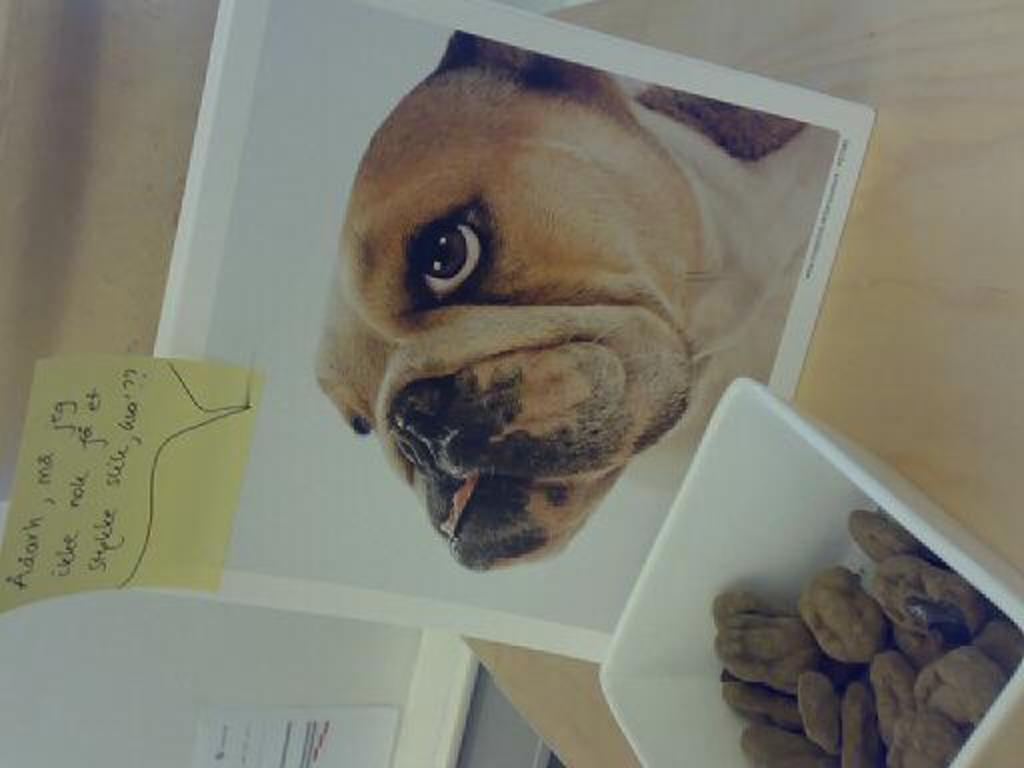Describe this image in one or two sentences. In this picture we can see a bowl with food items in it, photo of a dog with a sticker on it and these two are placed on a table and in the background we can see a poster on the wall. 